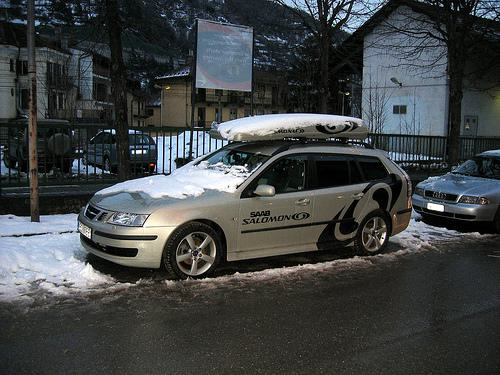What kind of equipment is mounted on the roof of the car in the foreground? The equipment mounted on the car's roof appears to be a cargo box, possibly used for carrying extra gear or luggage, particularly useful for travel or sporting activities. 